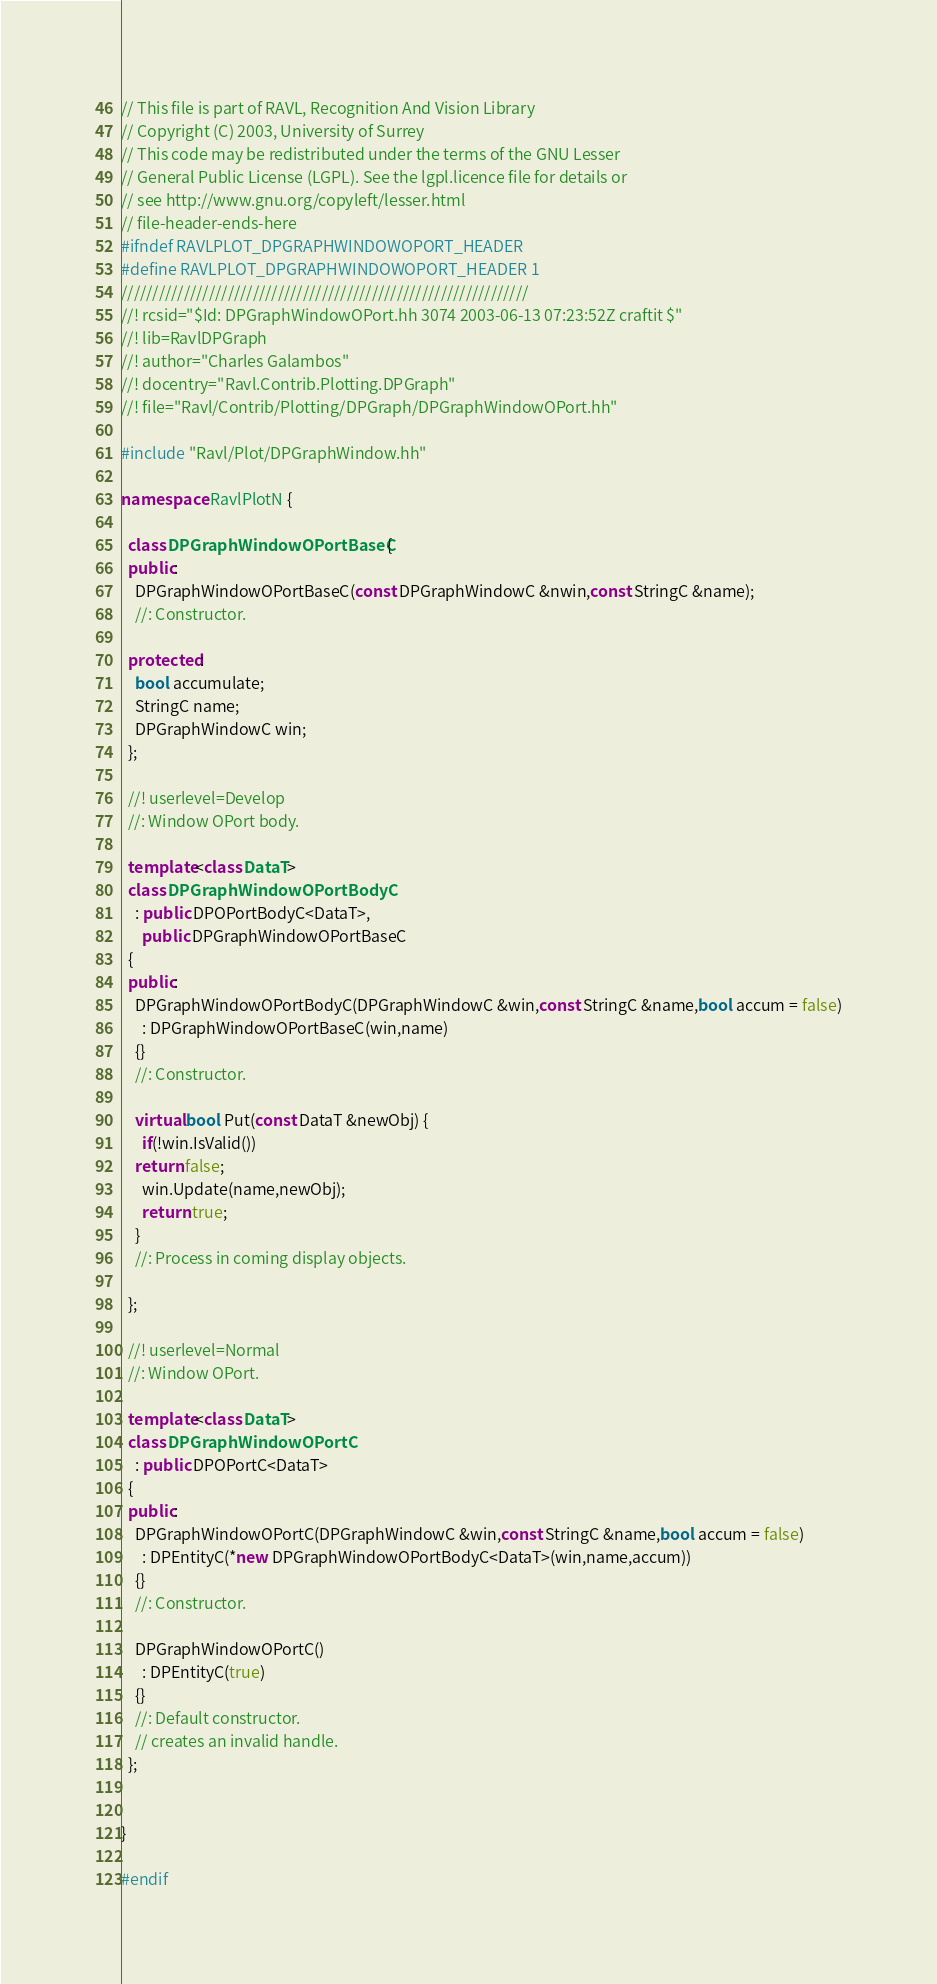<code> <loc_0><loc_0><loc_500><loc_500><_C++_>// This file is part of RAVL, Recognition And Vision Library 
// Copyright (C) 2003, University of Surrey
// This code may be redistributed under the terms of the GNU Lesser
// General Public License (LGPL). See the lgpl.licence file for details or
// see http://www.gnu.org/copyleft/lesser.html
// file-header-ends-here
#ifndef RAVLPLOT_DPGRAPHWINDOWOPORT_HEADER
#define RAVLPLOT_DPGRAPHWINDOWOPORT_HEADER 1
/////////////////////////////////////////////////////////////////
//! rcsid="$Id: DPGraphWindowOPort.hh 3074 2003-06-13 07:23:52Z craftit $"
//! lib=RavlDPGraph
//! author="Charles Galambos"
//! docentry="Ravl.Contrib.Plotting.DPGraph"
//! file="Ravl/Contrib/Plotting/DPGraph/DPGraphWindowOPort.hh"

#include "Ravl/Plot/DPGraphWindow.hh"

namespace RavlPlotN {

  class DPGraphWindowOPortBaseC {
  public:  
    DPGraphWindowOPortBaseC(const DPGraphWindowC &nwin,const StringC &name);
    //: Constructor.
    
  protected:
    bool accumulate;
    StringC name;
    DPGraphWindowC win;
  };
  
  //! userlevel=Develop
  //: Window OPort body.
  
  template<class DataT>
  class DPGraphWindowOPortBodyC
    : public DPOPortBodyC<DataT>,
      public DPGraphWindowOPortBaseC
  {
  public:
    DPGraphWindowOPortBodyC(DPGraphWindowC &win,const StringC &name,bool accum = false)
      : DPGraphWindowOPortBaseC(win,name)
    {}
    //: Constructor.
    
    virtual bool Put(const DataT &newObj) {
      if(!win.IsValid())
	return false;
      win.Update(name,newObj);
      return true;
    }
    //: Process in coming display objects.
    
  };

  //! userlevel=Normal
  //: Window OPort.
  
  template<class DataT>
  class DPGraphWindowOPortC
    : public DPOPortC<DataT>
  {
  public:
    DPGraphWindowOPortC(DPGraphWindowC &win,const StringC &name,bool accum = false)
      : DPEntityC(*new DPGraphWindowOPortBodyC<DataT>(win,name,accum))
    {}
    //: Constructor.
    
    DPGraphWindowOPortC()
      : DPEntityC(true)
    {}
    //: Default constructor.
    // creates an invalid handle.
  };
  
  
}

#endif
</code> 